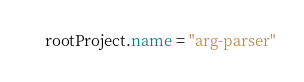<code> <loc_0><loc_0><loc_500><loc_500><_Kotlin_>rootProject.name = "arg-parser"
</code> 